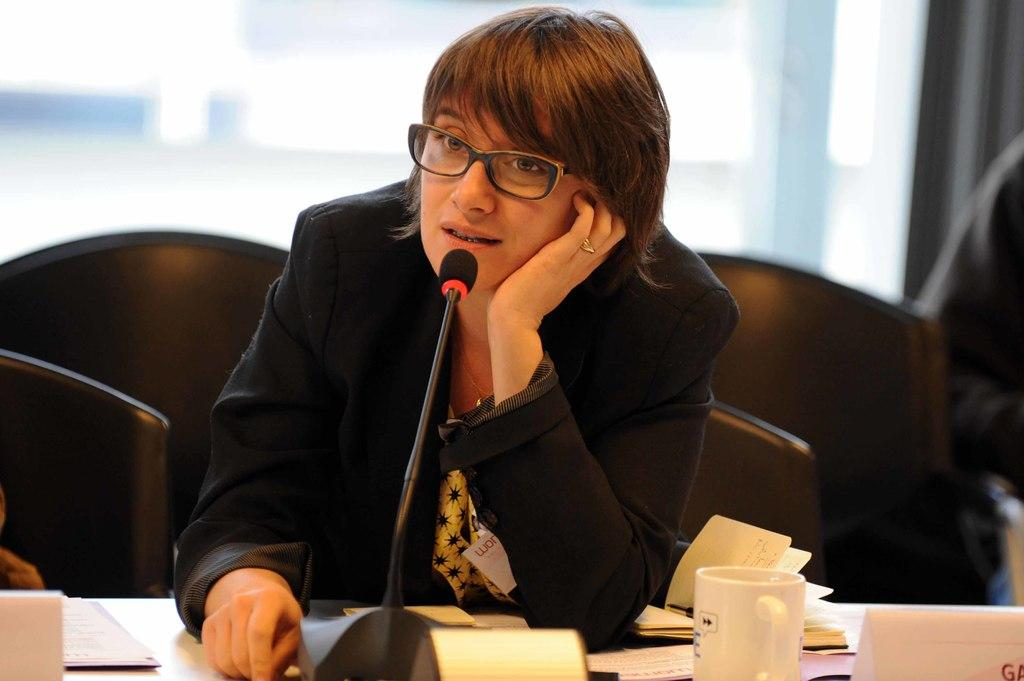Who is the main subject in the image? There is a woman in the image. What is the woman doing in the image? The woman is sitting and talking into a microphone. What is the woman wearing in the image? The woman is wearing a black coat and spectacles. What type of tank can be seen in the background of the image? There is no tank present in the image; it features a woman sitting and talking into a microphone. What book is the woman reading in the image? There is no book or reading activity depicted in the image. 